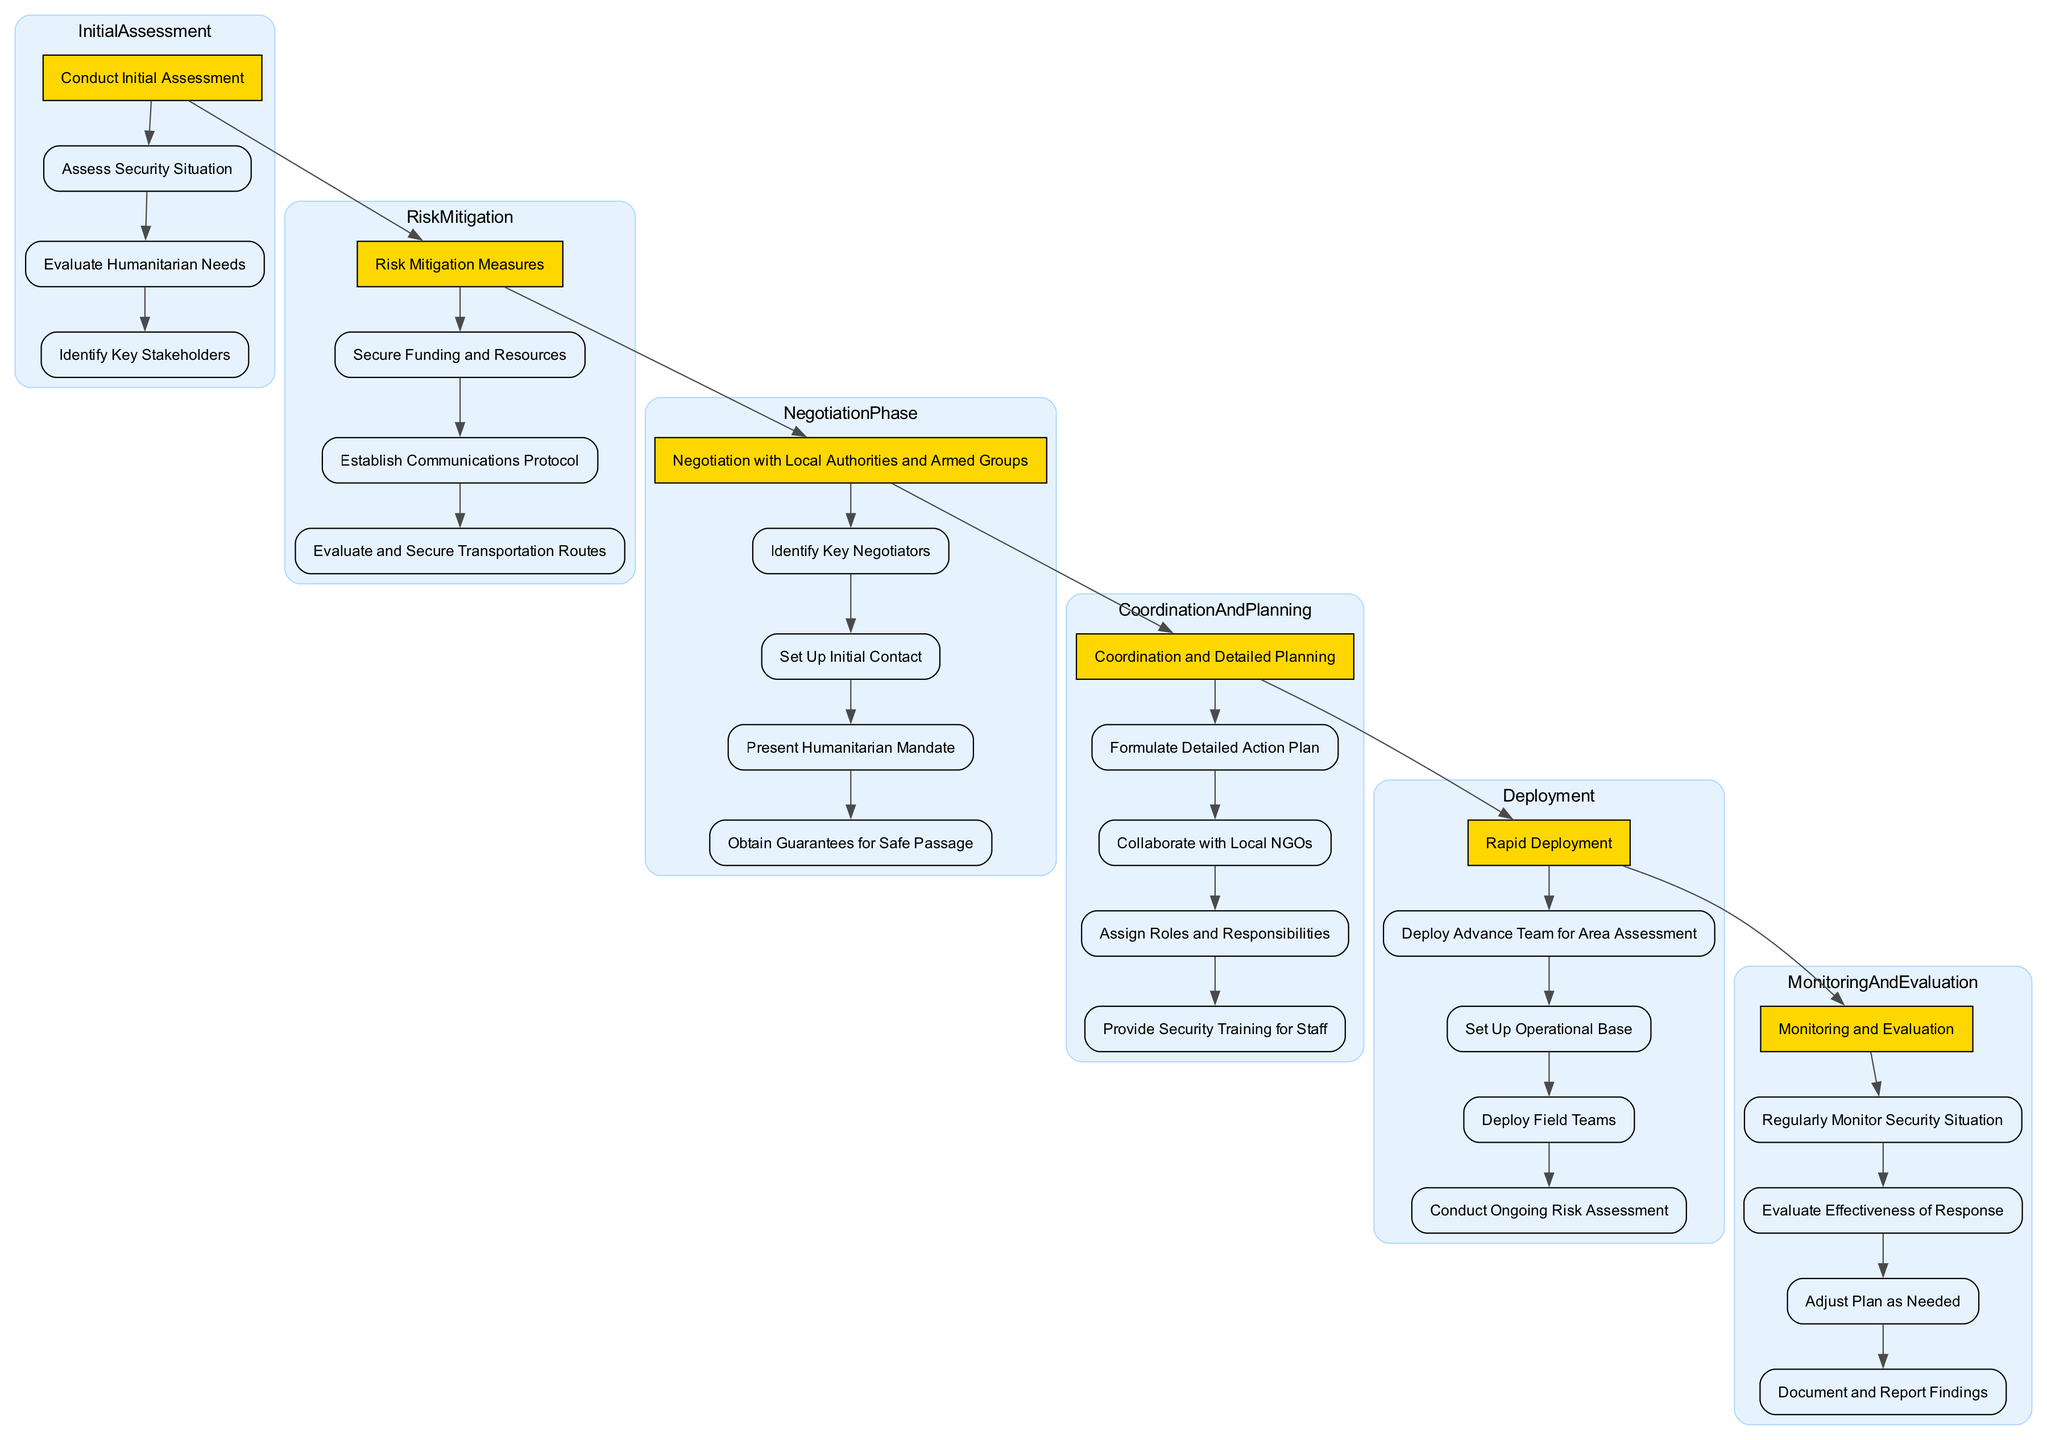What is the first step in the Initial Assessment phase? The first step in the Initial Assessment phase is "Assess Security Situation". This can be found by looking at the description for the Initial Assessment and identifying the first item listed under Steps.
Answer: Assess Security Situation How many steps are there in the Risk Mitigation phase? In the Risk Mitigation phase, there are three steps listed. This is determined by counting the items under the Steps for this phase.
Answer: 3 What follows after the Negotiation with Local Authorities and Armed Groups phase? After the Negotiation phase, the next phase is "Coordination and Detailed Planning". This is established by checking the order of the phases as represented in the diagram.
Answer: Coordination and Detailed Planning Which phase involves "Deploy Advance Team for Area Assessment"? The phase that involves "Deploy Advance Team for Area Assessment" is the Deployment phase. This step is specifically found under the Deployment's steps.
Answer: Deployment How many total phases are included in the Emergency Response Plan? The Emergency Response Plan consists of six phases in total. This can be verified by counting the main phase nodes in the diagram.
Answer: 6 What is the last step in the Monitoring and Evaluation phase? The last step in the Monitoring and Evaluation phase is "Document and Report Findings". This can be identified by looking at the last item in the Steps list for this particular phase.
Answer: Document and Report Findings What is the second step in the Coordination and Planning phase? The second step in Coordination and Planning phase is "Collaborate with Local NGOs". This is determined by identifying the items in the order they are presented under Steps for this phase.
Answer: Collaborate with Local NGOs What type of stakeholders are identified in the Initial Assessment phase? The type of stakeholders identified in the Initial Assessment phase are "Key Stakeholders". This is found by reviewing the steps listed under that phase.
Answer: Key Stakeholders Which step is immediately prior to "Obtain Guarantees for Safe Passage"? The step immediately prior to "Obtain Guarantees for Safe Passage" is "Present Humanitarian Mandate". This is found by reviewing the sequence of steps listed under the Negotiation phase.
Answer: Present Humanitarian Mandate 